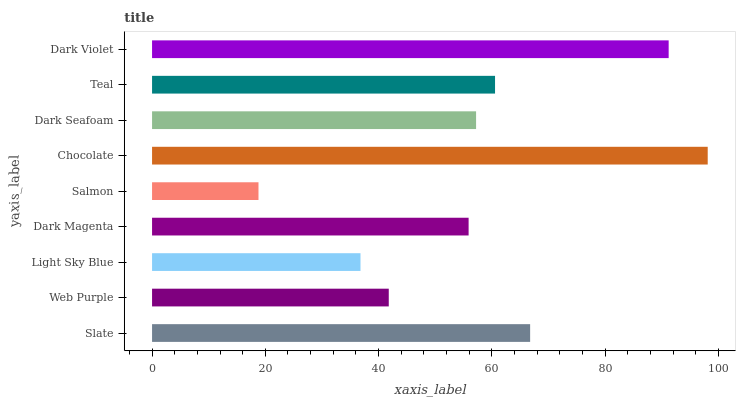Is Salmon the minimum?
Answer yes or no. Yes. Is Chocolate the maximum?
Answer yes or no. Yes. Is Web Purple the minimum?
Answer yes or no. No. Is Web Purple the maximum?
Answer yes or no. No. Is Slate greater than Web Purple?
Answer yes or no. Yes. Is Web Purple less than Slate?
Answer yes or no. Yes. Is Web Purple greater than Slate?
Answer yes or no. No. Is Slate less than Web Purple?
Answer yes or no. No. Is Dark Seafoam the high median?
Answer yes or no. Yes. Is Dark Seafoam the low median?
Answer yes or no. Yes. Is Dark Magenta the high median?
Answer yes or no. No. Is Web Purple the low median?
Answer yes or no. No. 